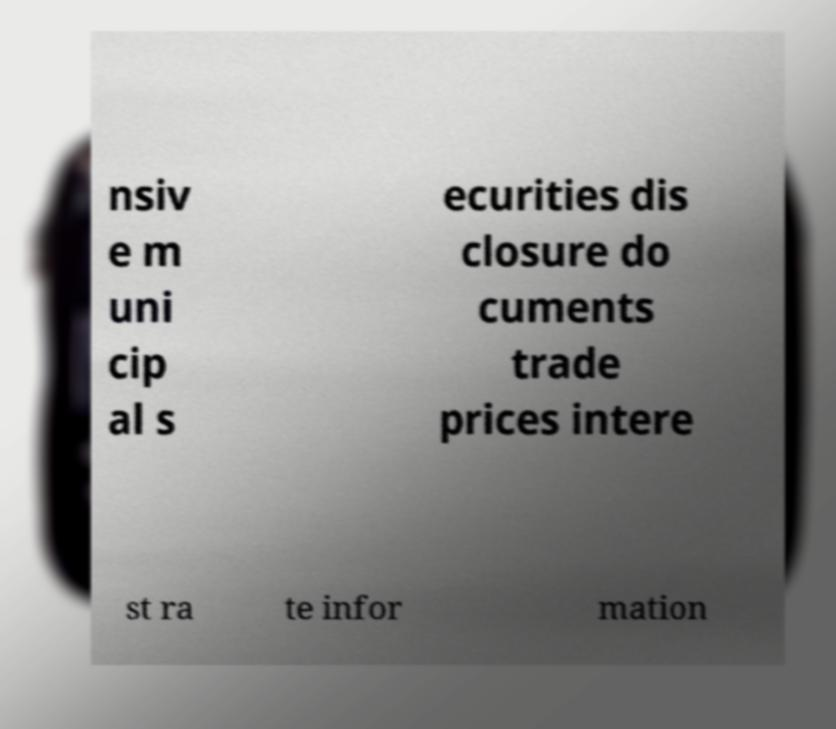Can you accurately transcribe the text from the provided image for me? nsiv e m uni cip al s ecurities dis closure do cuments trade prices intere st ra te infor mation 